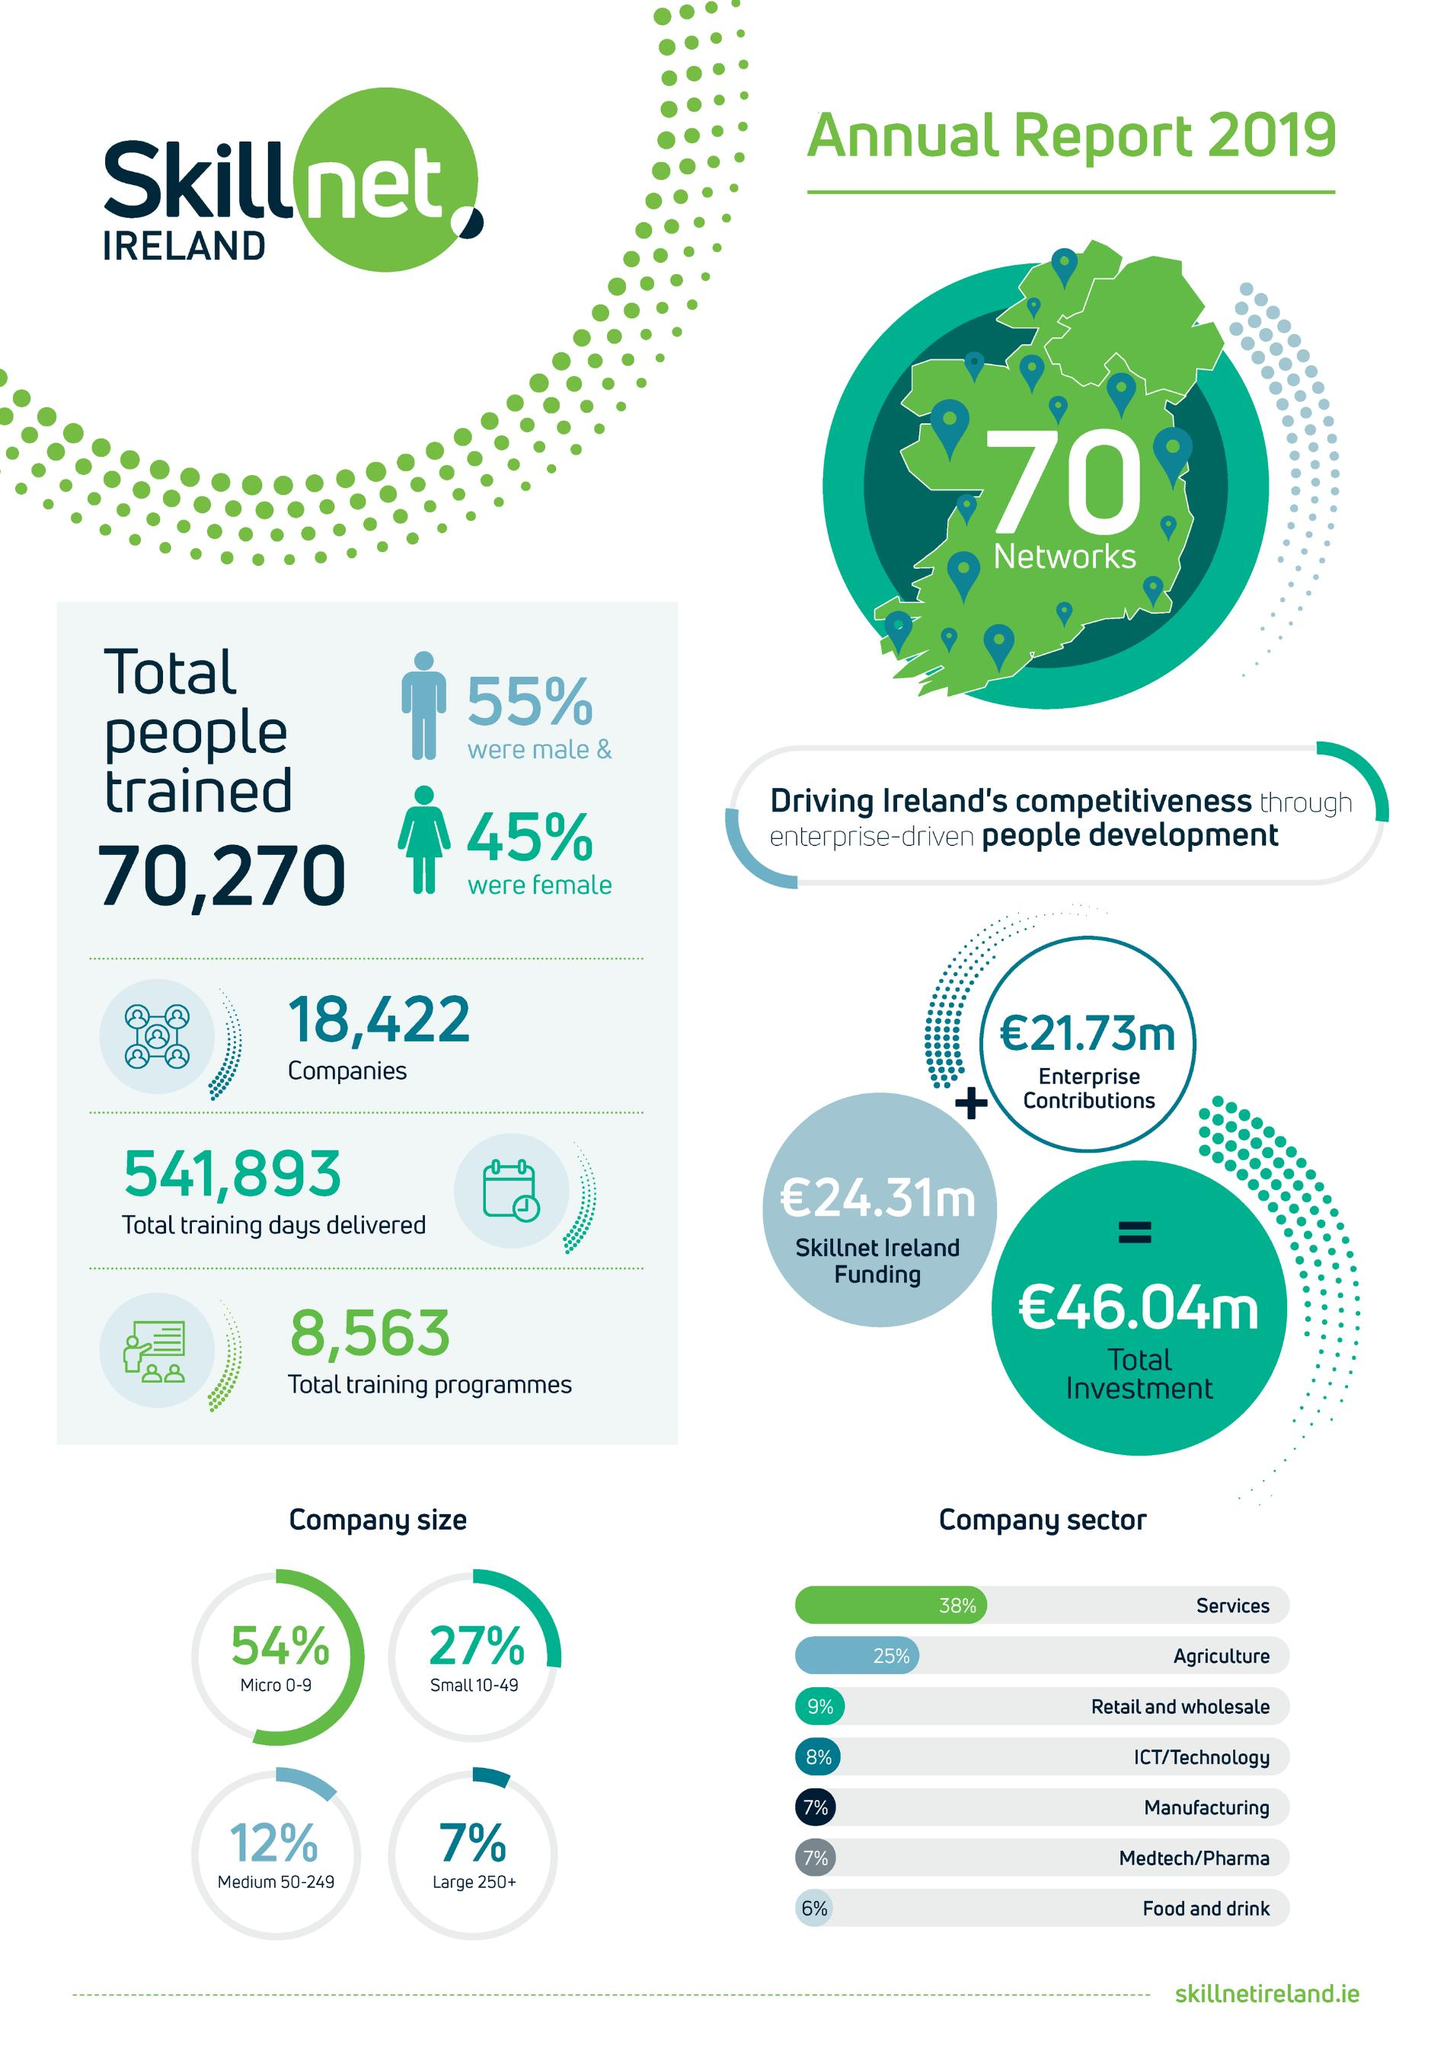Point out several critical features in this image. According to Skillnet Ireland, approximately 54% of small-sized companies have been trained by the organization. Additionally, 27% of small-sized companies and 25% of medium-sized companies have received training from Skillnet Ireland. Out of the manufacturing and pharmaceutical companies that participated in the Skillnet training program, 7% were successfully trained. 